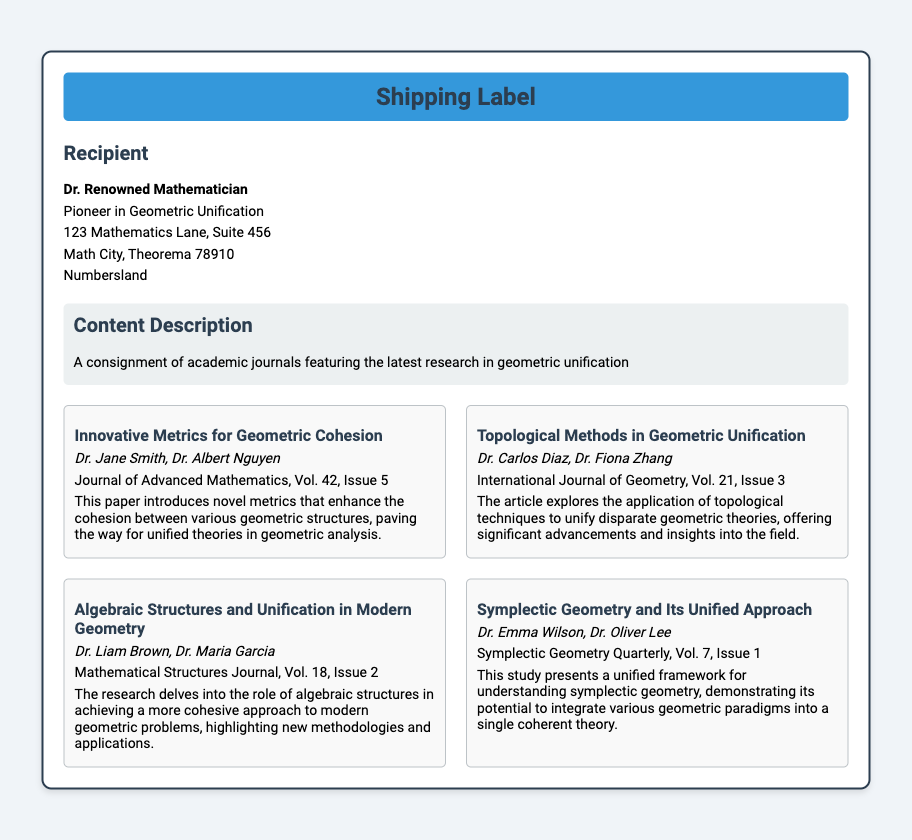What is the recipient's name? The recipient's name is prominently displayed in the document, which is Dr. Renowned Mathematician.
Answer: Dr. Renowned Mathematician What is the first article's title? The first article is listed with a title under the articles section, which is "Innovative Metrics for Geometric Cohesion."
Answer: Innovative Metrics for Geometric Cohesion Which journal published the article on topological methods? The journal for the article that discusses topological techniques is mentioned directly in its reference, which is the International Journal of Geometry.
Answer: International Journal of Geometry How many articles are listed in the document? The document specifies the total number of articles under the articles section and presents four distinct articles.
Answer: 4 Who are the authors of the article on algebraic structures? The authors are mentioned directly beneath the article title, which are Dr. Liam Brown and Dr. Maria Garcia.
Answer: Dr. Liam Brown, Dr. Maria Garcia What volume and issue is the "Symplectic Geometry and Its Unified Approach" article published in? This information is contained in the article reference, which indicates that it is in Volume 7, Issue 1.
Answer: Vol. 7, Issue 1 What is the main topic of the shipment? The content description provides a brief overview stating that the shipment includes academic journals focused on a specific topic.
Answer: Geometric unification Who sent the shipment? The document does not specify a sender, but includes the recipient information prominently displaying only the recipient's name and details.
Answer: Not specified 